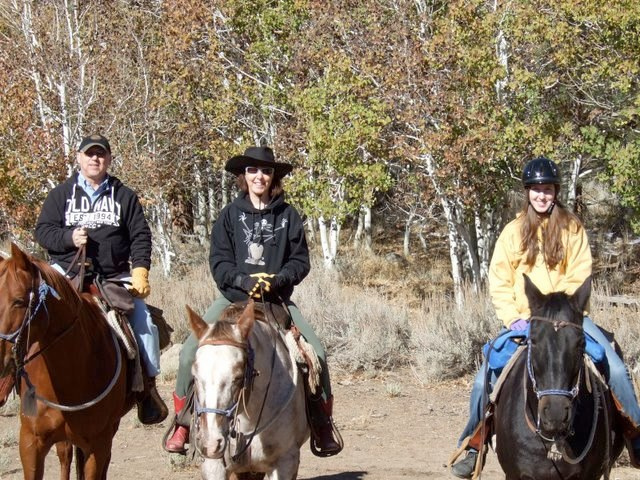Read and extract the text from this image. OLD NAVY ES EST 1994 